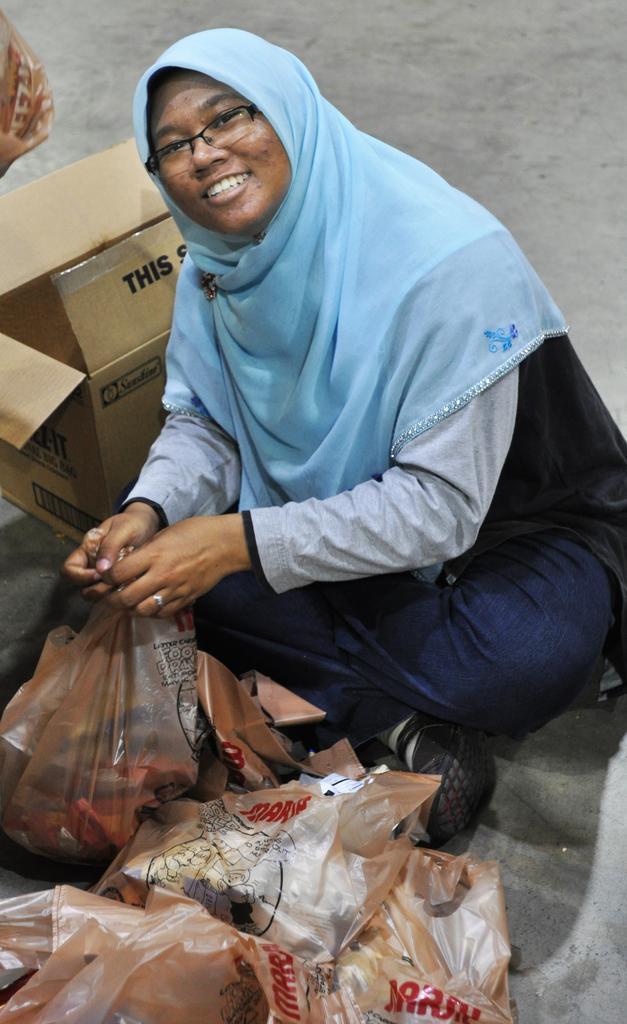Could you give a brief overview of what you see in this image? This is a zoomed in picture. In the foreground we can see the packet containing some items and there is a woman wearing blue color scarf and sitting on the ground. On the left we can see a box. In the background there is a ground. 